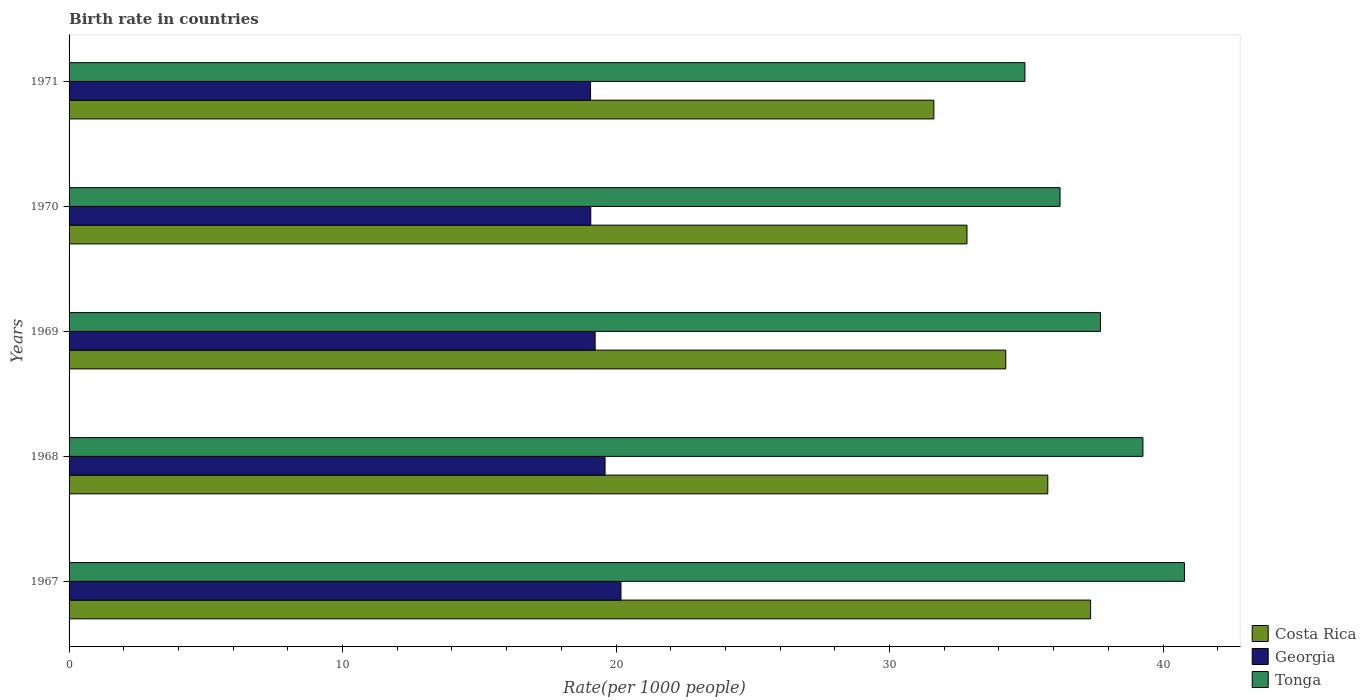How many groups of bars are there?
Give a very brief answer. 5. Are the number of bars per tick equal to the number of legend labels?
Provide a succinct answer. Yes. How many bars are there on the 1st tick from the top?
Provide a short and direct response. 3. What is the label of the 1st group of bars from the top?
Keep it short and to the point. 1971. What is the birth rate in Tonga in 1970?
Provide a short and direct response. 36.23. Across all years, what is the maximum birth rate in Georgia?
Your response must be concise. 20.18. Across all years, what is the minimum birth rate in Costa Rica?
Offer a very short reply. 31.62. In which year was the birth rate in Costa Rica maximum?
Your answer should be compact. 1967. In which year was the birth rate in Georgia minimum?
Keep it short and to the point. 1971. What is the total birth rate in Georgia in the graph?
Offer a very short reply. 97.16. What is the difference between the birth rate in Tonga in 1968 and that in 1970?
Give a very brief answer. 3.03. What is the difference between the birth rate in Georgia in 1971 and the birth rate in Costa Rica in 1968?
Offer a terse response. -16.72. What is the average birth rate in Costa Rica per year?
Give a very brief answer. 34.37. In the year 1971, what is the difference between the birth rate in Georgia and birth rate in Tonga?
Make the answer very short. -15.88. What is the ratio of the birth rate in Costa Rica in 1969 to that in 1971?
Make the answer very short. 1.08. Is the birth rate in Costa Rica in 1968 less than that in 1969?
Make the answer very short. No. Is the difference between the birth rate in Georgia in 1967 and 1971 greater than the difference between the birth rate in Tonga in 1967 and 1971?
Provide a succinct answer. No. What is the difference between the highest and the second highest birth rate in Costa Rica?
Provide a succinct answer. 1.56. What is the difference between the highest and the lowest birth rate in Tonga?
Give a very brief answer. 5.83. Is the sum of the birth rate in Georgia in 1969 and 1971 greater than the maximum birth rate in Costa Rica across all years?
Give a very brief answer. Yes. What does the 1st bar from the top in 1967 represents?
Provide a short and direct response. Tonga. What does the 3rd bar from the bottom in 1970 represents?
Offer a terse response. Tonga. How many bars are there?
Provide a short and direct response. 15. What is the difference between two consecutive major ticks on the X-axis?
Make the answer very short. 10. Does the graph contain any zero values?
Give a very brief answer. No. Where does the legend appear in the graph?
Ensure brevity in your answer.  Bottom right. How are the legend labels stacked?
Your answer should be very brief. Vertical. What is the title of the graph?
Keep it short and to the point. Birth rate in countries. What is the label or title of the X-axis?
Provide a short and direct response. Rate(per 1000 people). What is the label or title of the Y-axis?
Give a very brief answer. Years. What is the Rate(per 1000 people) in Costa Rica in 1967?
Keep it short and to the point. 37.35. What is the Rate(per 1000 people) of Georgia in 1967?
Your response must be concise. 20.18. What is the Rate(per 1000 people) in Tonga in 1967?
Make the answer very short. 40.78. What is the Rate(per 1000 people) in Costa Rica in 1968?
Keep it short and to the point. 35.79. What is the Rate(per 1000 people) of Georgia in 1968?
Offer a very short reply. 19.6. What is the Rate(per 1000 people) of Tonga in 1968?
Your response must be concise. 39.27. What is the Rate(per 1000 people) in Costa Rica in 1969?
Offer a very short reply. 34.25. What is the Rate(per 1000 people) in Georgia in 1969?
Your answer should be very brief. 19.24. What is the Rate(per 1000 people) of Tonga in 1969?
Your response must be concise. 37.71. What is the Rate(per 1000 people) of Costa Rica in 1970?
Make the answer very short. 32.83. What is the Rate(per 1000 people) of Georgia in 1970?
Provide a short and direct response. 19.08. What is the Rate(per 1000 people) of Tonga in 1970?
Your answer should be very brief. 36.23. What is the Rate(per 1000 people) in Costa Rica in 1971?
Provide a succinct answer. 31.62. What is the Rate(per 1000 people) of Georgia in 1971?
Give a very brief answer. 19.07. What is the Rate(per 1000 people) in Tonga in 1971?
Provide a succinct answer. 34.95. Across all years, what is the maximum Rate(per 1000 people) in Costa Rica?
Ensure brevity in your answer.  37.35. Across all years, what is the maximum Rate(per 1000 people) of Georgia?
Your answer should be very brief. 20.18. Across all years, what is the maximum Rate(per 1000 people) of Tonga?
Offer a terse response. 40.78. Across all years, what is the minimum Rate(per 1000 people) of Costa Rica?
Make the answer very short. 31.62. Across all years, what is the minimum Rate(per 1000 people) in Georgia?
Your answer should be compact. 19.07. Across all years, what is the minimum Rate(per 1000 people) of Tonga?
Your response must be concise. 34.95. What is the total Rate(per 1000 people) in Costa Rica in the graph?
Provide a succinct answer. 171.84. What is the total Rate(per 1000 people) of Georgia in the graph?
Make the answer very short. 97.16. What is the total Rate(per 1000 people) of Tonga in the graph?
Make the answer very short. 188.95. What is the difference between the Rate(per 1000 people) of Costa Rica in 1967 and that in 1968?
Offer a terse response. 1.56. What is the difference between the Rate(per 1000 people) of Georgia in 1967 and that in 1968?
Provide a succinct answer. 0.58. What is the difference between the Rate(per 1000 people) of Tonga in 1967 and that in 1968?
Keep it short and to the point. 1.52. What is the difference between the Rate(per 1000 people) of Costa Rica in 1967 and that in 1969?
Offer a very short reply. 3.1. What is the difference between the Rate(per 1000 people) in Georgia in 1967 and that in 1969?
Give a very brief answer. 0.94. What is the difference between the Rate(per 1000 people) of Tonga in 1967 and that in 1969?
Your answer should be very brief. 3.07. What is the difference between the Rate(per 1000 people) of Costa Rica in 1967 and that in 1970?
Offer a very short reply. 4.52. What is the difference between the Rate(per 1000 people) of Georgia in 1967 and that in 1970?
Provide a short and direct response. 1.1. What is the difference between the Rate(per 1000 people) in Tonga in 1967 and that in 1970?
Offer a very short reply. 4.55. What is the difference between the Rate(per 1000 people) in Costa Rica in 1967 and that in 1971?
Provide a short and direct response. 5.73. What is the difference between the Rate(per 1000 people) in Georgia in 1967 and that in 1971?
Ensure brevity in your answer.  1.11. What is the difference between the Rate(per 1000 people) in Tonga in 1967 and that in 1971?
Offer a very short reply. 5.83. What is the difference between the Rate(per 1000 people) in Costa Rica in 1968 and that in 1969?
Keep it short and to the point. 1.54. What is the difference between the Rate(per 1000 people) of Georgia in 1968 and that in 1969?
Offer a very short reply. 0.36. What is the difference between the Rate(per 1000 people) in Tonga in 1968 and that in 1969?
Offer a terse response. 1.55. What is the difference between the Rate(per 1000 people) of Costa Rica in 1968 and that in 1970?
Your answer should be very brief. 2.96. What is the difference between the Rate(per 1000 people) of Georgia in 1968 and that in 1970?
Provide a succinct answer. 0.52. What is the difference between the Rate(per 1000 people) in Tonga in 1968 and that in 1970?
Give a very brief answer. 3.03. What is the difference between the Rate(per 1000 people) in Costa Rica in 1968 and that in 1971?
Your answer should be very brief. 4.17. What is the difference between the Rate(per 1000 people) in Georgia in 1968 and that in 1971?
Provide a succinct answer. 0.53. What is the difference between the Rate(per 1000 people) in Tonga in 1968 and that in 1971?
Your answer should be compact. 4.32. What is the difference between the Rate(per 1000 people) in Costa Rica in 1969 and that in 1970?
Offer a terse response. 1.42. What is the difference between the Rate(per 1000 people) in Georgia in 1969 and that in 1970?
Give a very brief answer. 0.16. What is the difference between the Rate(per 1000 people) in Tonga in 1969 and that in 1970?
Give a very brief answer. 1.48. What is the difference between the Rate(per 1000 people) in Costa Rica in 1969 and that in 1971?
Your response must be concise. 2.63. What is the difference between the Rate(per 1000 people) in Georgia in 1969 and that in 1971?
Ensure brevity in your answer.  0.17. What is the difference between the Rate(per 1000 people) of Tonga in 1969 and that in 1971?
Offer a terse response. 2.76. What is the difference between the Rate(per 1000 people) in Costa Rica in 1970 and that in 1971?
Offer a terse response. 1.21. What is the difference between the Rate(per 1000 people) of Georgia in 1970 and that in 1971?
Provide a short and direct response. 0.01. What is the difference between the Rate(per 1000 people) of Tonga in 1970 and that in 1971?
Ensure brevity in your answer.  1.28. What is the difference between the Rate(per 1000 people) of Costa Rica in 1967 and the Rate(per 1000 people) of Georgia in 1968?
Provide a succinct answer. 17.75. What is the difference between the Rate(per 1000 people) in Costa Rica in 1967 and the Rate(per 1000 people) in Tonga in 1968?
Your answer should be compact. -1.91. What is the difference between the Rate(per 1000 people) in Georgia in 1967 and the Rate(per 1000 people) in Tonga in 1968?
Make the answer very short. -19.09. What is the difference between the Rate(per 1000 people) of Costa Rica in 1967 and the Rate(per 1000 people) of Georgia in 1969?
Your answer should be compact. 18.12. What is the difference between the Rate(per 1000 people) of Costa Rica in 1967 and the Rate(per 1000 people) of Tonga in 1969?
Offer a very short reply. -0.36. What is the difference between the Rate(per 1000 people) in Georgia in 1967 and the Rate(per 1000 people) in Tonga in 1969?
Offer a terse response. -17.53. What is the difference between the Rate(per 1000 people) in Costa Rica in 1967 and the Rate(per 1000 people) in Georgia in 1970?
Provide a succinct answer. 18.28. What is the difference between the Rate(per 1000 people) in Costa Rica in 1967 and the Rate(per 1000 people) in Tonga in 1970?
Your response must be concise. 1.12. What is the difference between the Rate(per 1000 people) of Georgia in 1967 and the Rate(per 1000 people) of Tonga in 1970?
Provide a succinct answer. -16.05. What is the difference between the Rate(per 1000 people) of Costa Rica in 1967 and the Rate(per 1000 people) of Georgia in 1971?
Give a very brief answer. 18.28. What is the difference between the Rate(per 1000 people) in Costa Rica in 1967 and the Rate(per 1000 people) in Tonga in 1971?
Your answer should be compact. 2.4. What is the difference between the Rate(per 1000 people) in Georgia in 1967 and the Rate(per 1000 people) in Tonga in 1971?
Make the answer very short. -14.77. What is the difference between the Rate(per 1000 people) in Costa Rica in 1968 and the Rate(per 1000 people) in Georgia in 1969?
Offer a terse response. 16.55. What is the difference between the Rate(per 1000 people) of Costa Rica in 1968 and the Rate(per 1000 people) of Tonga in 1969?
Offer a very short reply. -1.93. What is the difference between the Rate(per 1000 people) of Georgia in 1968 and the Rate(per 1000 people) of Tonga in 1969?
Offer a terse response. -18.11. What is the difference between the Rate(per 1000 people) in Costa Rica in 1968 and the Rate(per 1000 people) in Georgia in 1970?
Keep it short and to the point. 16.71. What is the difference between the Rate(per 1000 people) of Costa Rica in 1968 and the Rate(per 1000 people) of Tonga in 1970?
Ensure brevity in your answer.  -0.45. What is the difference between the Rate(per 1000 people) of Georgia in 1968 and the Rate(per 1000 people) of Tonga in 1970?
Provide a short and direct response. -16.64. What is the difference between the Rate(per 1000 people) of Costa Rica in 1968 and the Rate(per 1000 people) of Georgia in 1971?
Offer a terse response. 16.72. What is the difference between the Rate(per 1000 people) in Costa Rica in 1968 and the Rate(per 1000 people) in Tonga in 1971?
Offer a terse response. 0.84. What is the difference between the Rate(per 1000 people) in Georgia in 1968 and the Rate(per 1000 people) in Tonga in 1971?
Your answer should be very brief. -15.35. What is the difference between the Rate(per 1000 people) of Costa Rica in 1969 and the Rate(per 1000 people) of Georgia in 1970?
Offer a terse response. 15.17. What is the difference between the Rate(per 1000 people) in Costa Rica in 1969 and the Rate(per 1000 people) in Tonga in 1970?
Your response must be concise. -1.99. What is the difference between the Rate(per 1000 people) in Georgia in 1969 and the Rate(per 1000 people) in Tonga in 1970?
Your answer should be compact. -17. What is the difference between the Rate(per 1000 people) of Costa Rica in 1969 and the Rate(per 1000 people) of Georgia in 1971?
Make the answer very short. 15.18. What is the difference between the Rate(per 1000 people) in Costa Rica in 1969 and the Rate(per 1000 people) in Tonga in 1971?
Provide a short and direct response. -0.7. What is the difference between the Rate(per 1000 people) in Georgia in 1969 and the Rate(per 1000 people) in Tonga in 1971?
Provide a succinct answer. -15.71. What is the difference between the Rate(per 1000 people) in Costa Rica in 1970 and the Rate(per 1000 people) in Georgia in 1971?
Keep it short and to the point. 13.76. What is the difference between the Rate(per 1000 people) in Costa Rica in 1970 and the Rate(per 1000 people) in Tonga in 1971?
Make the answer very short. -2.12. What is the difference between the Rate(per 1000 people) in Georgia in 1970 and the Rate(per 1000 people) in Tonga in 1971?
Provide a succinct answer. -15.88. What is the average Rate(per 1000 people) of Costa Rica per year?
Offer a terse response. 34.37. What is the average Rate(per 1000 people) of Georgia per year?
Provide a succinct answer. 19.43. What is the average Rate(per 1000 people) of Tonga per year?
Make the answer very short. 37.79. In the year 1967, what is the difference between the Rate(per 1000 people) of Costa Rica and Rate(per 1000 people) of Georgia?
Provide a short and direct response. 17.17. In the year 1967, what is the difference between the Rate(per 1000 people) of Costa Rica and Rate(per 1000 people) of Tonga?
Keep it short and to the point. -3.43. In the year 1967, what is the difference between the Rate(per 1000 people) of Georgia and Rate(per 1000 people) of Tonga?
Your response must be concise. -20.6. In the year 1968, what is the difference between the Rate(per 1000 people) in Costa Rica and Rate(per 1000 people) in Georgia?
Ensure brevity in your answer.  16.19. In the year 1968, what is the difference between the Rate(per 1000 people) in Costa Rica and Rate(per 1000 people) in Tonga?
Provide a succinct answer. -3.48. In the year 1968, what is the difference between the Rate(per 1000 people) of Georgia and Rate(per 1000 people) of Tonga?
Offer a terse response. -19.67. In the year 1969, what is the difference between the Rate(per 1000 people) in Costa Rica and Rate(per 1000 people) in Georgia?
Make the answer very short. 15.01. In the year 1969, what is the difference between the Rate(per 1000 people) in Costa Rica and Rate(per 1000 people) in Tonga?
Ensure brevity in your answer.  -3.46. In the year 1969, what is the difference between the Rate(per 1000 people) of Georgia and Rate(per 1000 people) of Tonga?
Your answer should be compact. -18.48. In the year 1970, what is the difference between the Rate(per 1000 people) in Costa Rica and Rate(per 1000 people) in Georgia?
Keep it short and to the point. 13.76. In the year 1970, what is the difference between the Rate(per 1000 people) of Costa Rica and Rate(per 1000 people) of Tonga?
Your answer should be compact. -3.4. In the year 1970, what is the difference between the Rate(per 1000 people) in Georgia and Rate(per 1000 people) in Tonga?
Provide a short and direct response. -17.16. In the year 1971, what is the difference between the Rate(per 1000 people) in Costa Rica and Rate(per 1000 people) in Georgia?
Ensure brevity in your answer.  12.55. In the year 1971, what is the difference between the Rate(per 1000 people) in Costa Rica and Rate(per 1000 people) in Tonga?
Give a very brief answer. -3.33. In the year 1971, what is the difference between the Rate(per 1000 people) in Georgia and Rate(per 1000 people) in Tonga?
Make the answer very short. -15.88. What is the ratio of the Rate(per 1000 people) of Costa Rica in 1967 to that in 1968?
Your answer should be very brief. 1.04. What is the ratio of the Rate(per 1000 people) in Georgia in 1967 to that in 1968?
Offer a very short reply. 1.03. What is the ratio of the Rate(per 1000 people) of Tonga in 1967 to that in 1968?
Your response must be concise. 1.04. What is the ratio of the Rate(per 1000 people) in Costa Rica in 1967 to that in 1969?
Your answer should be very brief. 1.09. What is the ratio of the Rate(per 1000 people) in Georgia in 1967 to that in 1969?
Provide a short and direct response. 1.05. What is the ratio of the Rate(per 1000 people) of Tonga in 1967 to that in 1969?
Provide a succinct answer. 1.08. What is the ratio of the Rate(per 1000 people) of Costa Rica in 1967 to that in 1970?
Your answer should be very brief. 1.14. What is the ratio of the Rate(per 1000 people) in Georgia in 1967 to that in 1970?
Your response must be concise. 1.06. What is the ratio of the Rate(per 1000 people) of Tonga in 1967 to that in 1970?
Your response must be concise. 1.13. What is the ratio of the Rate(per 1000 people) of Costa Rica in 1967 to that in 1971?
Offer a very short reply. 1.18. What is the ratio of the Rate(per 1000 people) in Georgia in 1967 to that in 1971?
Your response must be concise. 1.06. What is the ratio of the Rate(per 1000 people) in Tonga in 1967 to that in 1971?
Offer a terse response. 1.17. What is the ratio of the Rate(per 1000 people) of Costa Rica in 1968 to that in 1969?
Make the answer very short. 1.04. What is the ratio of the Rate(per 1000 people) of Georgia in 1968 to that in 1969?
Make the answer very short. 1.02. What is the ratio of the Rate(per 1000 people) in Tonga in 1968 to that in 1969?
Make the answer very short. 1.04. What is the ratio of the Rate(per 1000 people) of Costa Rica in 1968 to that in 1970?
Offer a terse response. 1.09. What is the ratio of the Rate(per 1000 people) in Georgia in 1968 to that in 1970?
Make the answer very short. 1.03. What is the ratio of the Rate(per 1000 people) of Tonga in 1968 to that in 1970?
Offer a terse response. 1.08. What is the ratio of the Rate(per 1000 people) in Costa Rica in 1968 to that in 1971?
Give a very brief answer. 1.13. What is the ratio of the Rate(per 1000 people) in Georgia in 1968 to that in 1971?
Your answer should be compact. 1.03. What is the ratio of the Rate(per 1000 people) of Tonga in 1968 to that in 1971?
Your answer should be compact. 1.12. What is the ratio of the Rate(per 1000 people) of Costa Rica in 1969 to that in 1970?
Offer a very short reply. 1.04. What is the ratio of the Rate(per 1000 people) of Georgia in 1969 to that in 1970?
Your answer should be very brief. 1.01. What is the ratio of the Rate(per 1000 people) in Tonga in 1969 to that in 1970?
Your answer should be compact. 1.04. What is the ratio of the Rate(per 1000 people) of Costa Rica in 1969 to that in 1971?
Provide a short and direct response. 1.08. What is the ratio of the Rate(per 1000 people) of Georgia in 1969 to that in 1971?
Ensure brevity in your answer.  1.01. What is the ratio of the Rate(per 1000 people) of Tonga in 1969 to that in 1971?
Provide a succinct answer. 1.08. What is the ratio of the Rate(per 1000 people) of Costa Rica in 1970 to that in 1971?
Provide a succinct answer. 1.04. What is the ratio of the Rate(per 1000 people) in Georgia in 1970 to that in 1971?
Your answer should be compact. 1. What is the ratio of the Rate(per 1000 people) of Tonga in 1970 to that in 1971?
Your answer should be very brief. 1.04. What is the difference between the highest and the second highest Rate(per 1000 people) in Costa Rica?
Give a very brief answer. 1.56. What is the difference between the highest and the second highest Rate(per 1000 people) of Georgia?
Give a very brief answer. 0.58. What is the difference between the highest and the second highest Rate(per 1000 people) in Tonga?
Ensure brevity in your answer.  1.52. What is the difference between the highest and the lowest Rate(per 1000 people) in Costa Rica?
Your response must be concise. 5.73. What is the difference between the highest and the lowest Rate(per 1000 people) in Georgia?
Ensure brevity in your answer.  1.11. What is the difference between the highest and the lowest Rate(per 1000 people) in Tonga?
Make the answer very short. 5.83. 